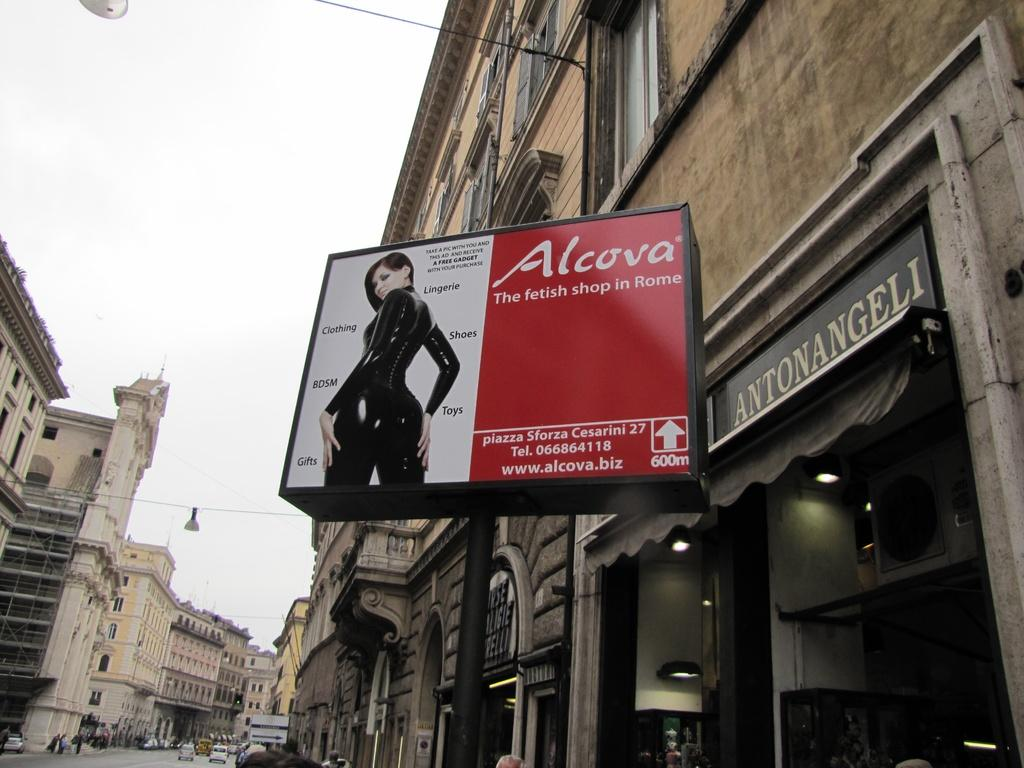<image>
Relay a brief, clear account of the picture shown. A sign with a woman.promoting the Alcova departmentstore 